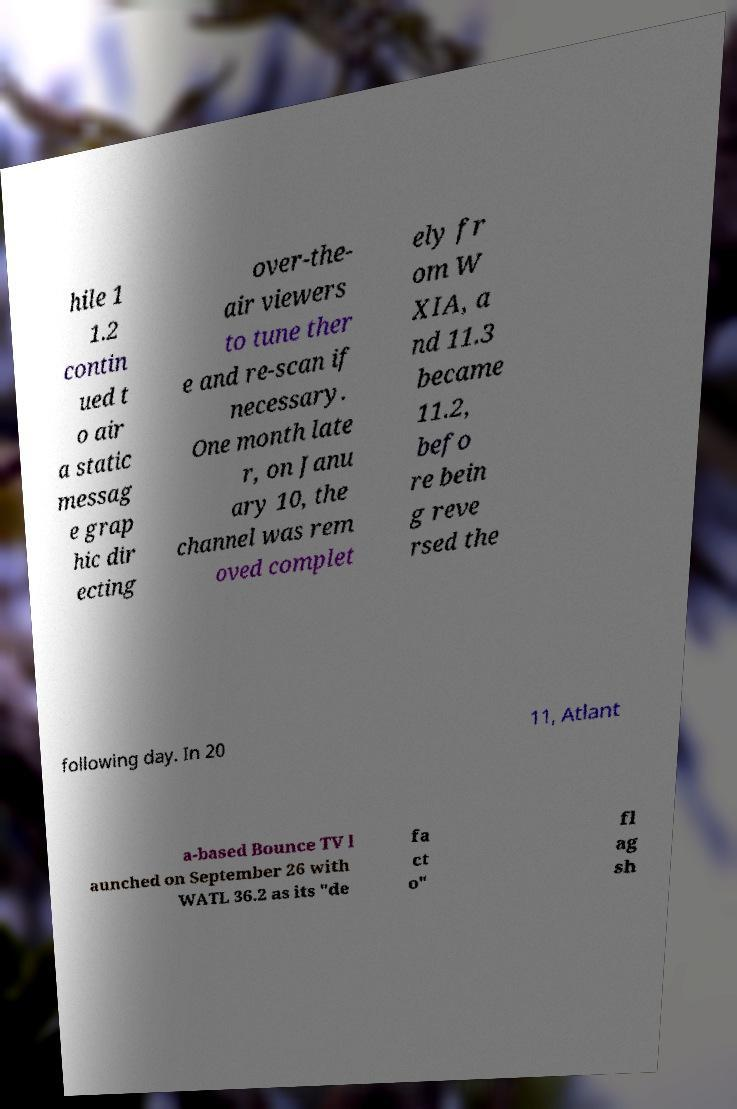Please read and relay the text visible in this image. What does it say? hile 1 1.2 contin ued t o air a static messag e grap hic dir ecting over-the- air viewers to tune ther e and re-scan if necessary. One month late r, on Janu ary 10, the channel was rem oved complet ely fr om W XIA, a nd 11.3 became 11.2, befo re bein g reve rsed the following day. In 20 11, Atlant a-based Bounce TV l aunched on September 26 with WATL 36.2 as its "de fa ct o" fl ag sh 